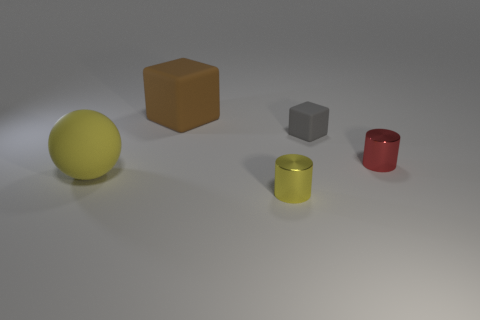Add 2 tiny purple shiny cylinders. How many objects exist? 7 Subtract all balls. How many objects are left? 4 Subtract 0 cyan blocks. How many objects are left? 5 Subtract 1 balls. How many balls are left? 0 Subtract all blue cylinders. Subtract all blue cubes. How many cylinders are left? 2 Subtract all blue cubes. How many red cylinders are left? 1 Subtract all small rubber blocks. Subtract all matte things. How many objects are left? 1 Add 5 matte blocks. How many matte blocks are left? 7 Add 5 small metal cylinders. How many small metal cylinders exist? 7 